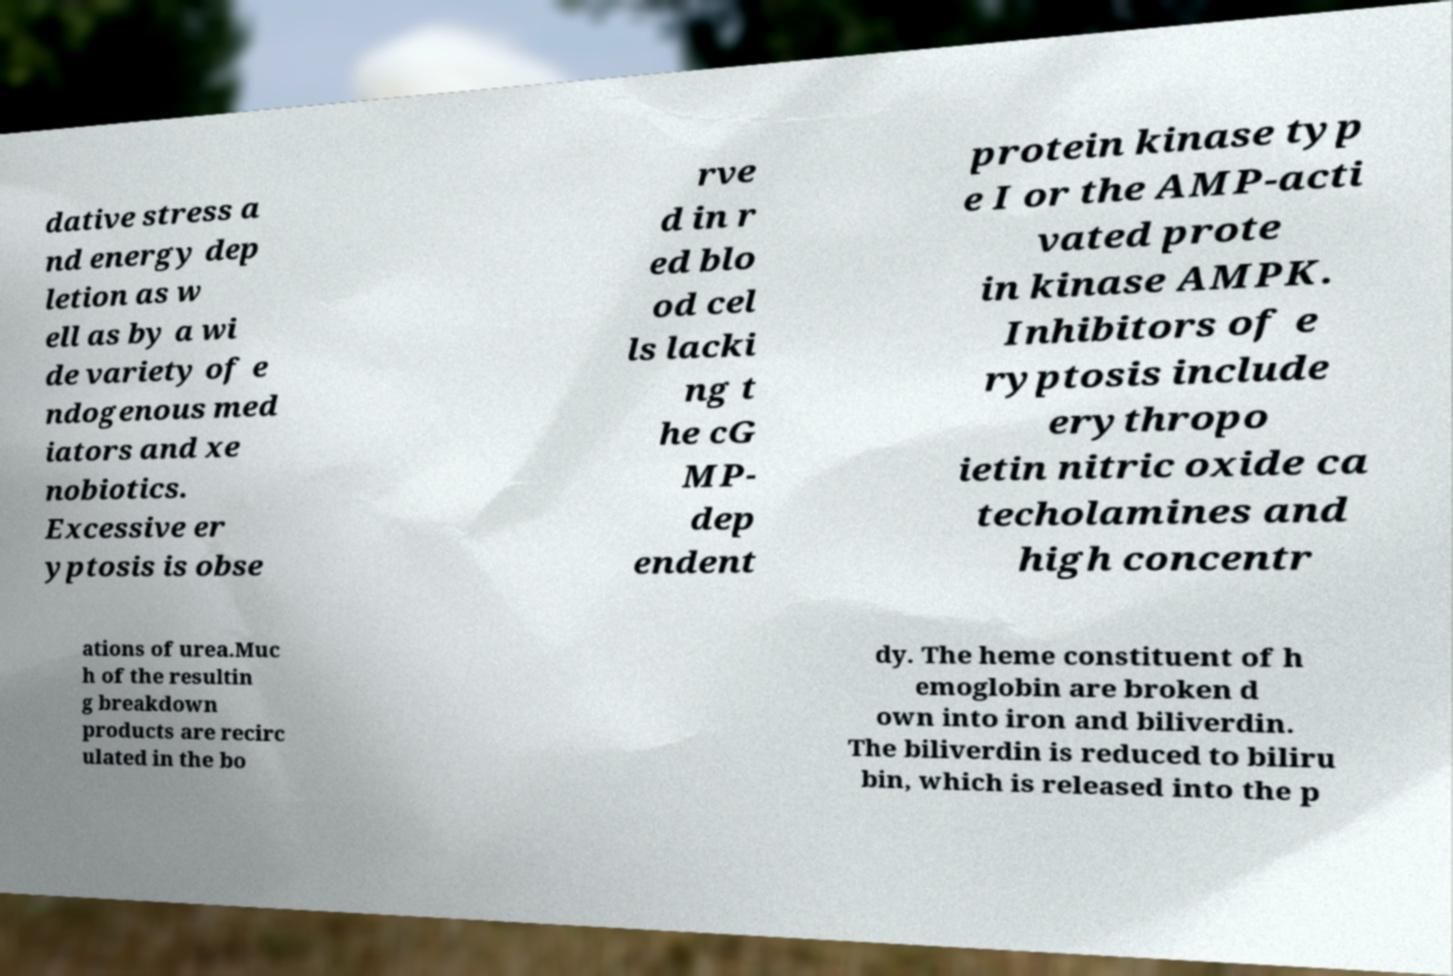Please identify and transcribe the text found in this image. dative stress a nd energy dep letion as w ell as by a wi de variety of e ndogenous med iators and xe nobiotics. Excessive er yptosis is obse rve d in r ed blo od cel ls lacki ng t he cG MP- dep endent protein kinase typ e I or the AMP-acti vated prote in kinase AMPK. Inhibitors of e ryptosis include erythropo ietin nitric oxide ca techolamines and high concentr ations of urea.Muc h of the resultin g breakdown products are recirc ulated in the bo dy. The heme constituent of h emoglobin are broken d own into iron and biliverdin. The biliverdin is reduced to biliru bin, which is released into the p 